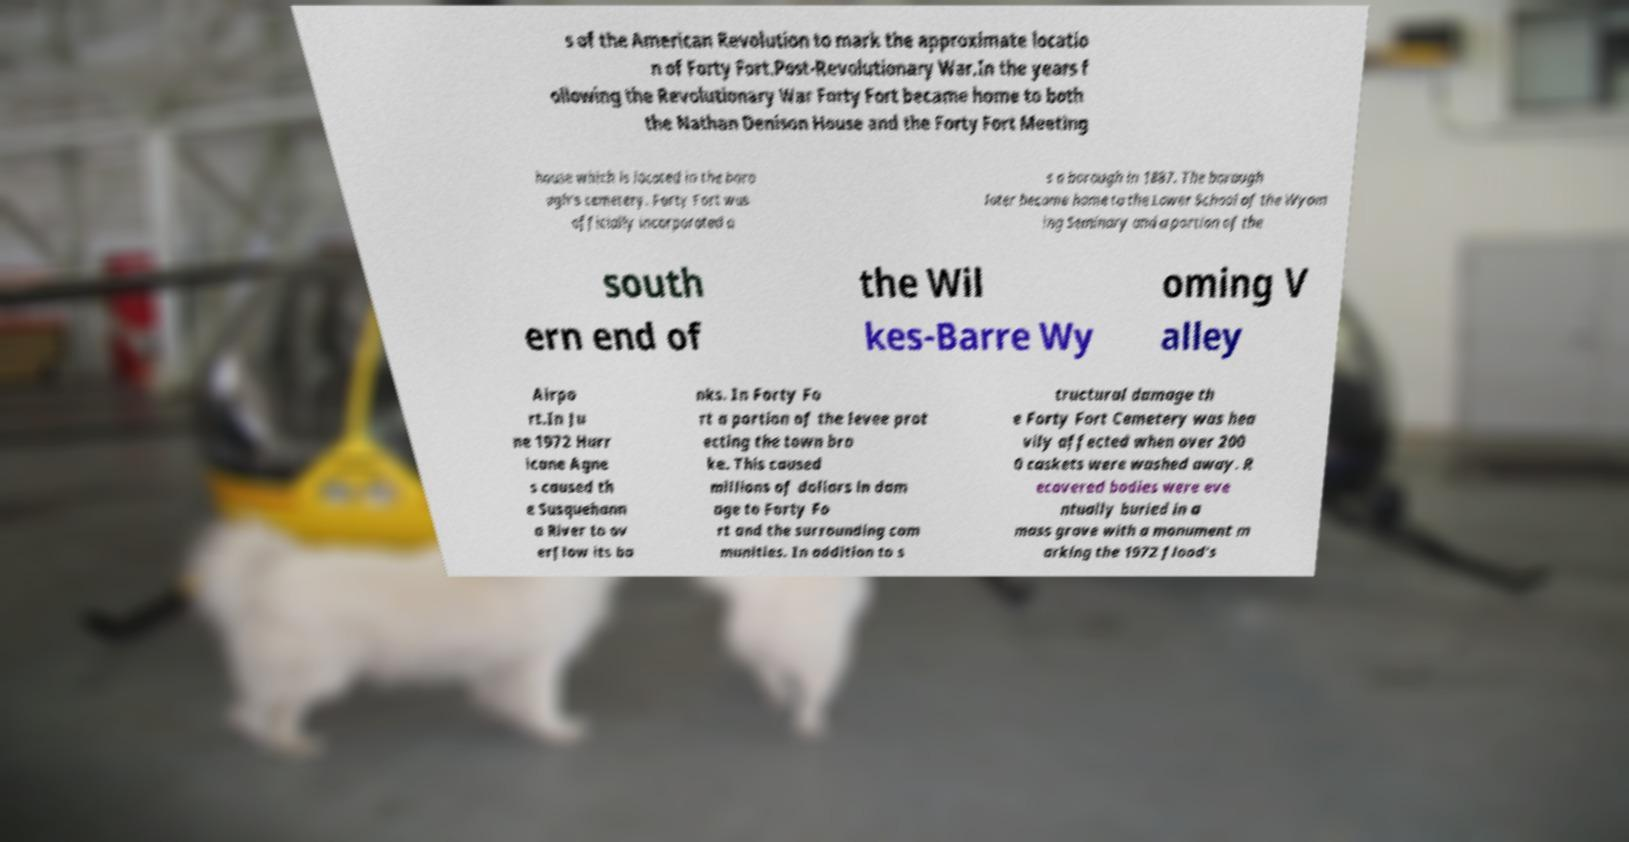Please read and relay the text visible in this image. What does it say? s of the American Revolution to mark the approximate locatio n of Forty Fort.Post-Revolutionary War.In the years f ollowing the Revolutionary War Forty Fort became home to both the Nathan Denison House and the Forty Fort Meeting house which is located in the boro ugh's cemetery. Forty Fort was officially incorporated a s a borough in 1887. The borough later became home to the Lower School of the Wyom ing Seminary and a portion of the south ern end of the Wil kes-Barre Wy oming V alley Airpo rt.In Ju ne 1972 Hurr icane Agne s caused th e Susquehann a River to ov erflow its ba nks. In Forty Fo rt a portion of the levee prot ecting the town bro ke. This caused millions of dollars in dam age to Forty Fo rt and the surrounding com munities. In addition to s tructural damage th e Forty Fort Cemetery was hea vily affected when over 200 0 caskets were washed away. R ecovered bodies were eve ntually buried in a mass grave with a monument m arking the 1972 flood's 